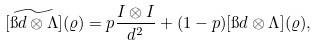<formula> <loc_0><loc_0><loc_500><loc_500>[ \widetilde { \i d \otimes \Lambda } ] ( \varrho ) = p \frac { I \otimes I } { d ^ { 2 } } + ( 1 - p ) [ \i d \otimes \Lambda ] ( \varrho ) ,</formula> 